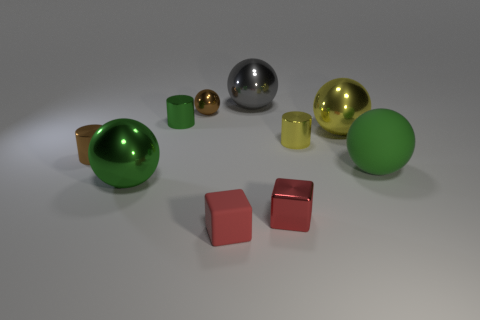What number of other things are there of the same size as the green metal cylinder?
Make the answer very short. 5. How many large green things are both on the left side of the small matte object and to the right of the big yellow ball?
Your answer should be very brief. 0. Is the big green sphere that is on the left side of the brown ball made of the same material as the green cylinder?
Provide a short and direct response. Yes. What shape is the tiny shiny thing that is in front of the big green thing that is right of the cylinder right of the small red metallic block?
Ensure brevity in your answer.  Cube. Are there the same number of green balls that are behind the green rubber object and tiny green things in front of the brown sphere?
Your answer should be very brief. No. The rubber ball that is the same size as the gray metallic object is what color?
Your answer should be very brief. Green. How many large objects are either green metal balls or green matte balls?
Provide a succinct answer. 2. There is a big object that is both in front of the tiny yellow object and to the left of the yellow shiny sphere; what is its material?
Give a very brief answer. Metal. Do the large metal object to the right of the big gray metal object and the green thing that is on the right side of the big yellow sphere have the same shape?
Keep it short and to the point. Yes. What shape is the tiny shiny object that is the same color as the big rubber ball?
Keep it short and to the point. Cylinder. 